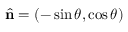<formula> <loc_0><loc_0><loc_500><loc_500>\hat { n } = \left ( - \sin \theta , \cos \theta \right )</formula> 